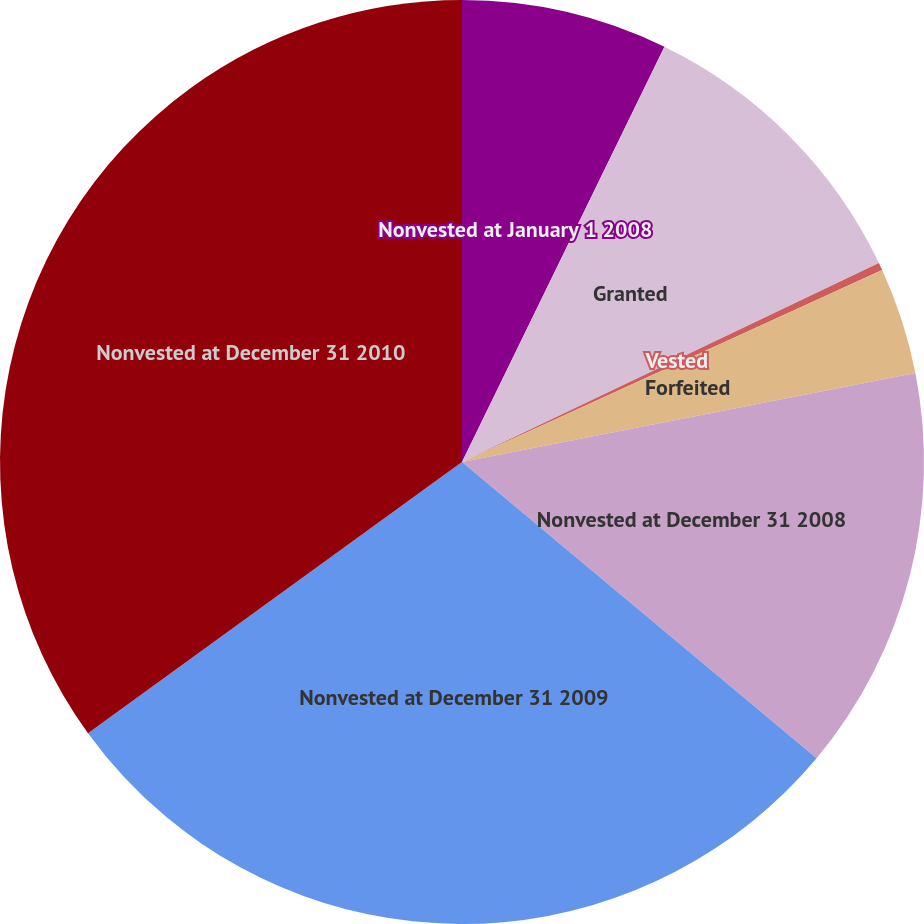Convert chart to OTSL. <chart><loc_0><loc_0><loc_500><loc_500><pie_chart><fcel>Nonvested at January 1 2008<fcel>Granted<fcel>Vested<fcel>Forfeited<fcel>Nonvested at December 31 2008<fcel>Nonvested at December 31 2009<fcel>Nonvested at December 31 2010<nl><fcel>7.22%<fcel>10.69%<fcel>0.27%<fcel>3.74%<fcel>14.16%<fcel>28.94%<fcel>34.99%<nl></chart> 